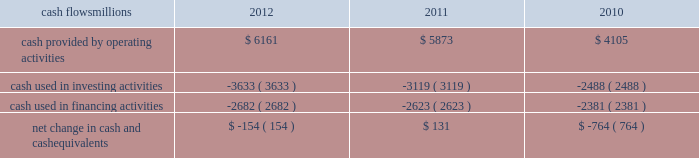At december 31 , 2012 and 2011 , we had a working capital surplus .
This reflects a strong cash position , which provides enhanced liquidity in an uncertain economic environment .
In addition , we believe we have adequate access to capital markets to meet any foreseeable cash requirements , and we have sufficient financial capacity to satisfy our current liabilities .
Cash flows millions 2012 2011 2010 .
Operating activities higher net income in 2012 increased cash provided by operating activities compared to 2011 , partially offset by lower tax benefits from bonus depreciation ( as explained below ) and payments for past wages based on national labor negotiations settled earlier this year .
Higher net income and lower cash income tax payments in 2011 increased cash provided by operating activities compared to 2010 .
The tax relief , unemployment insurance reauthorization , and job creation act of 2010 provided for 100% ( 100 % ) bonus depreciation for qualified investments made during 2011 , and 50% ( 50 % ) bonus depreciation for qualified investments made during 2012 .
As a result of the act , the company deferred a substantial portion of its 2011 income tax expense .
This deferral decreased 2011 income tax payments , thereby contributing to the positive operating cash flow .
In future years , however , additional cash will be used to pay income taxes that were previously deferred .
In addition , the adoption of a new accounting standard in january of 2010 changed the accounting treatment for our receivables securitization facility from a sale of undivided interests ( recorded as an operating activity ) to a secured borrowing ( recorded as a financing activity ) , which decreased cash provided by operating activities by $ 400 million in 2010 .
Investing activities higher capital investments in 2012 drove the increase in cash used in investing activities compared to 2011 .
Included in capital investments in 2012 was $ 75 million for the early buyout of 165 locomotives under long-term operating and capital leases during the first quarter of 2012 , which we exercised due to favorable economic terms and market conditions .
Higher capital investments partially offset by higher proceeds from asset sales in 2011 drove the increase in cash used in investing activities compared to 2010. .
What was the average cost per locomotive for the 2012 early buyout? 
Computations: ((75 * 1000000) / 165)
Answer: 454545.45455. 